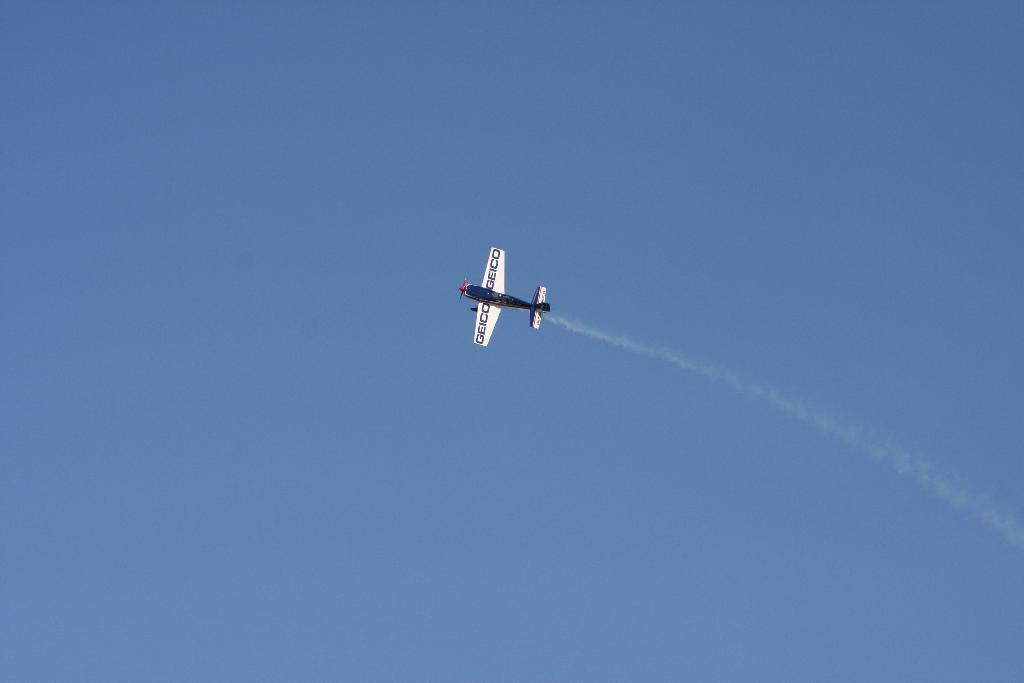What is the main subject of the picture? The main subject of the picture is a jet plane. What colors are used to paint the jet plane? The jet plane is in white, blue, and red colors. What is the jet plane doing in the picture? The jet plane is flying in the sky. What can be seen in the background of the image? The sky is visible in the background of the image. What is the color of the sky in the picture? The sky is blue in color. What type of event is taking place in the image? There is no specific event taking place in the image; it simply shows a jet plane flying in the sky. How many thumbs can be seen on the jet plane in the image? There are no thumbs visible on the jet plane in the image, as it is a machine and not a living being. 